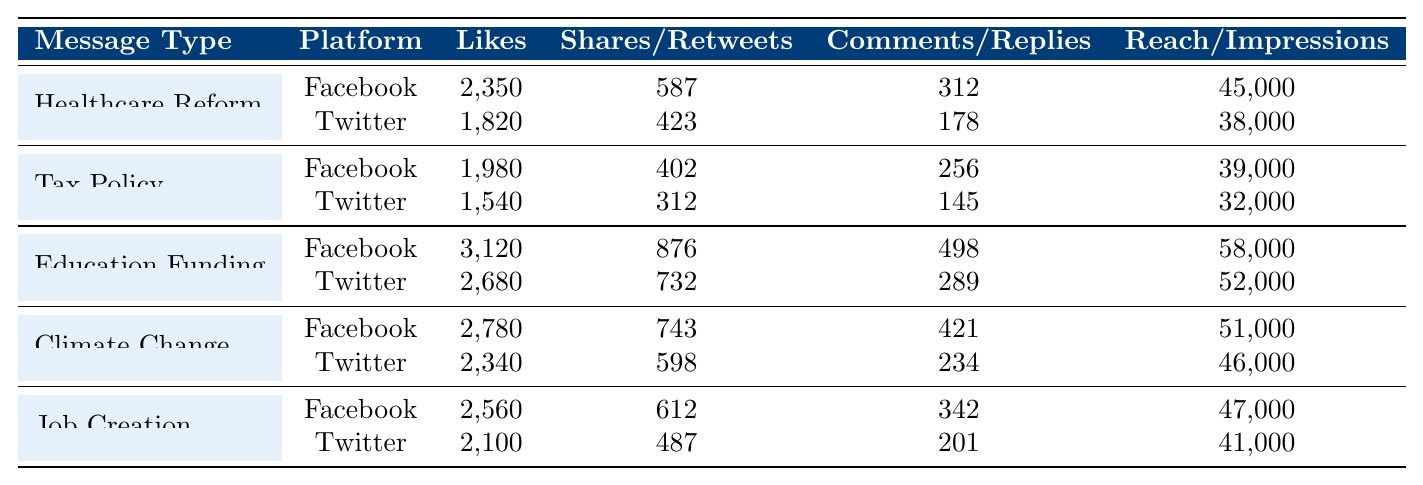What is the highest number of likes for a campaign message on Facebook? Looking at the Facebook likes for each message type, the highest is 3,120 for Education Funding.
Answer: 3,120 Which campaign message received the most shares on Facebook? The shares for each message on Facebook show that Education Funding received the most shares with 876.
Answer: Education Funding What is the total number of comments for Tax Policy across both platforms? For Tax Policy, comments are 256 on Facebook and 145 on Twitter. Summing these gives 256 + 145 = 401.
Answer: 401 Which Twitter post had more impressions, Climate Change or Job Creation? Climate Change had 46,000 impressions while Job Creation had 41,000 impressions. Since 46,000 > 41,000, Climate Change had more impressions.
Answer: Climate Change What is the average reach for all campaign messages on Facebook? The reaches for Facebook are 45,000 (Healthcare Reform), 39,000 (Tax Policy), 58,000 (Education Funding), 51,000 (Climate Change), and 47,000 (Job Creation). The total reach is 45,000 + 39,000 + 58,000 + 51,000 + 47,000 = 240,000. The average is 240,000 / 5 = 48,000.
Answer: 48,000 Did any Twitter message receive more replies than the Healthcare Reform message? Healthcare Reform had 178 replies on Twitter. The replies for other Twitter messages are 145 (Tax Policy), 289 (Education Funding), 234 (Climate Change), and 201 (Job Creation). Only Education Funding had more replies than 178.
Answer: Yes What is the difference in likes between the most and least liked message type on Twitter? The highest likes on Twitter is 2,680 for Education Funding, and the lowest is 1,540 for Tax Policy. The difference is 2,680 - 1,540 = 1,140.
Answer: 1,140 On which platform did Job Creation have higher engagement, Facebook or Twitter? Engagement can be evaluated by summing likes, shares (or retweets), and comments (or replies). Facebook: 2560 likes + 612 shares + 342 comments = 3514. Twitter: 2100 likes + 487 retweets + 201 replies = 2788. Since 3514 > 2788, Job Creation had higher engagement on Facebook.
Answer: Facebook 